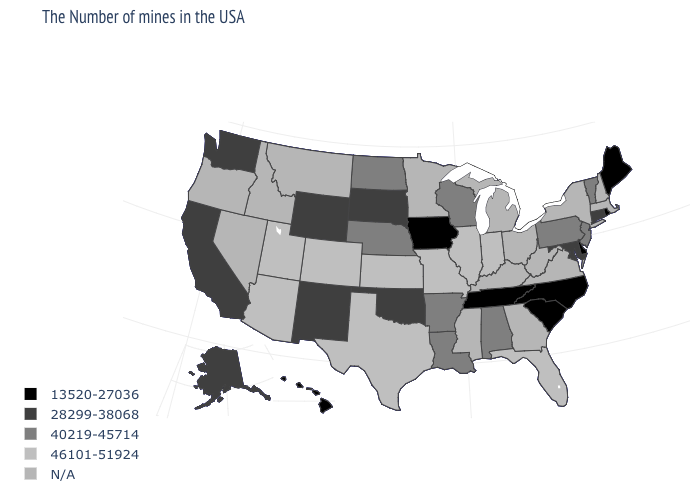What is the value of Utah?
Short answer required. 46101-51924. How many symbols are there in the legend?
Be succinct. 5. Among the states that border Kansas , which have the highest value?
Answer briefly. Missouri, Colorado. Does the map have missing data?
Quick response, please. Yes. What is the value of Tennessee?
Concise answer only. 13520-27036. Name the states that have a value in the range N/A?
Be succinct. Massachusetts, New Hampshire, New York, Virginia, West Virginia, Ohio, Georgia, Michigan, Kentucky, Mississippi, Minnesota, Montana, Idaho, Nevada, Oregon. Does the first symbol in the legend represent the smallest category?
Answer briefly. Yes. What is the value of Missouri?
Concise answer only. 46101-51924. Among the states that border Virginia , does Tennessee have the lowest value?
Keep it brief. Yes. Which states have the highest value in the USA?
Be succinct. Florida, Indiana, Illinois, Missouri, Kansas, Texas, Colorado, Utah, Arizona. Which states have the lowest value in the USA?
Short answer required. Maine, Rhode Island, Delaware, North Carolina, South Carolina, Tennessee, Iowa, Hawaii. Does New Jersey have the highest value in the Northeast?
Answer briefly. Yes. Does the map have missing data?
Give a very brief answer. Yes. Among the states that border New Mexico , does Oklahoma have the lowest value?
Keep it brief. Yes. 